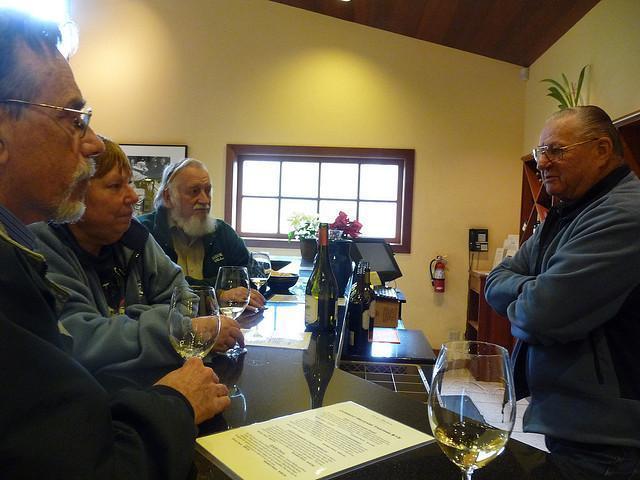How many people can be seen?
Give a very brief answer. 4. How many wine glasses are there?
Give a very brief answer. 2. How many black dogs are on the bed?
Give a very brief answer. 0. 